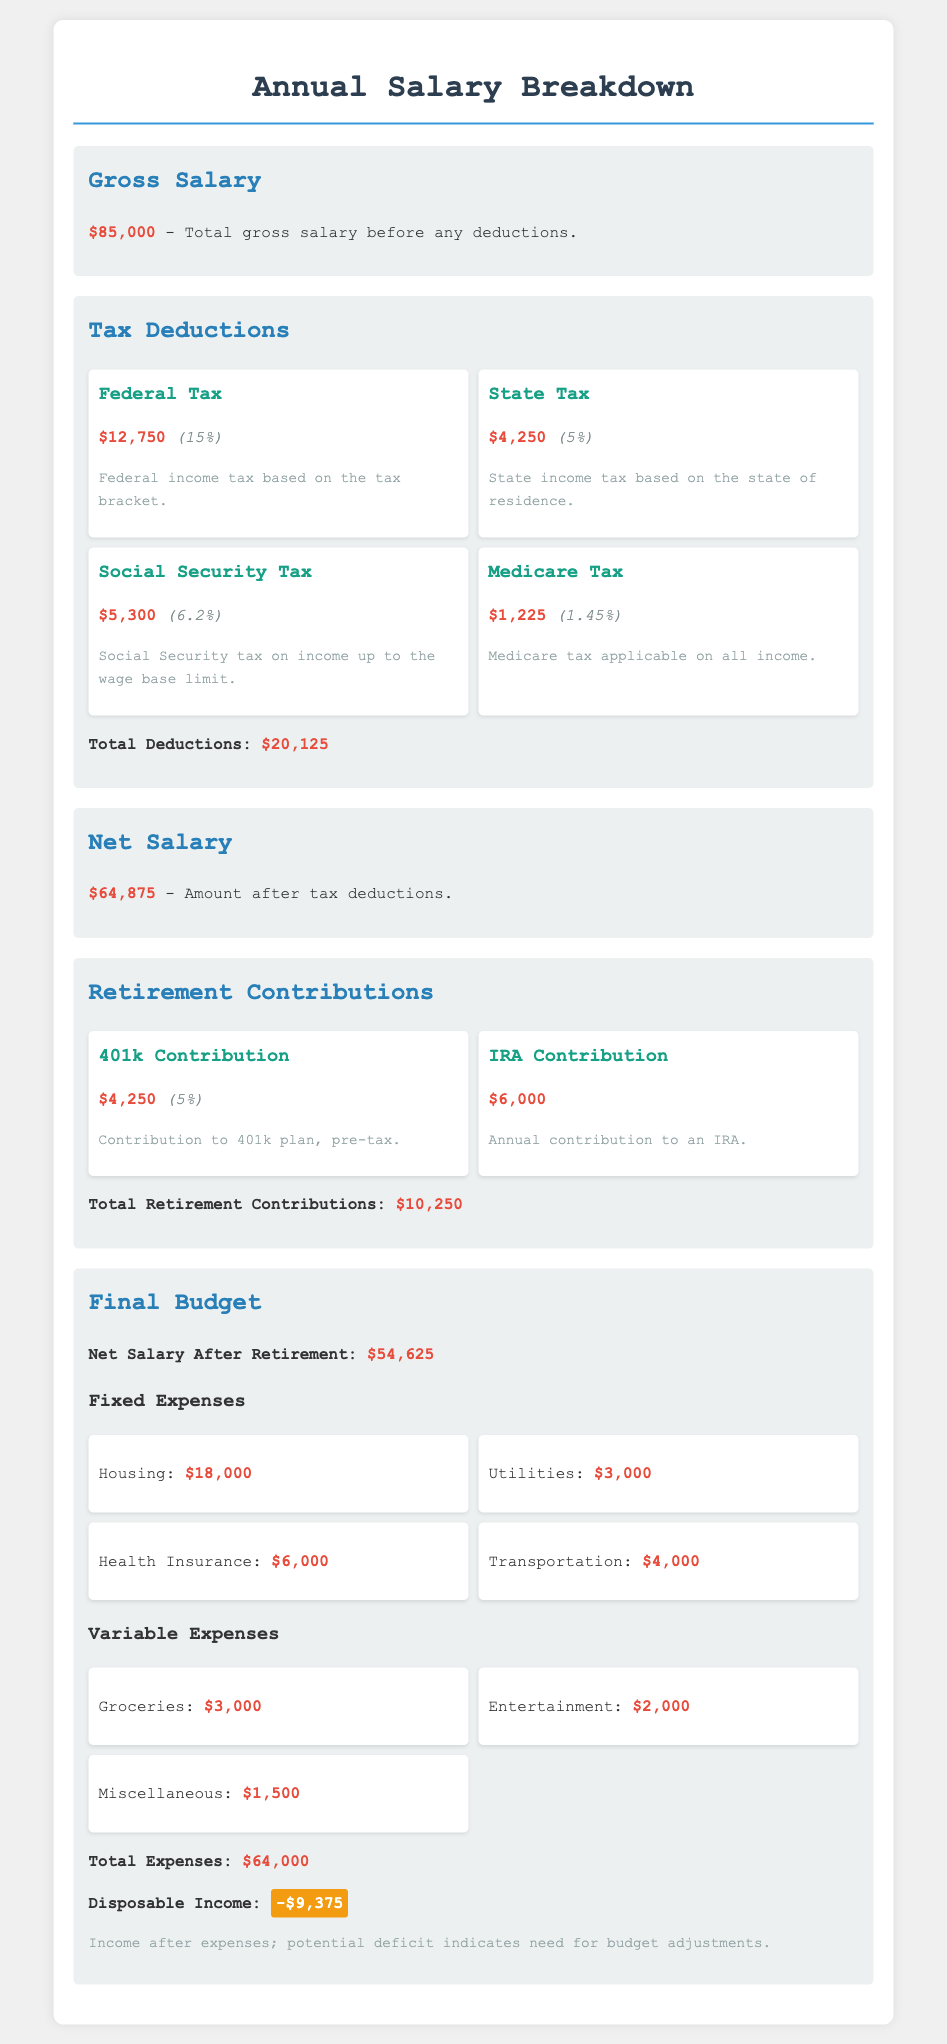what is the gross salary? The gross salary is stated in the document as the total salary before deductions, which is $85,000.
Answer: $85,000 what is the total amount of tax deductions? The total deductions amount is provided in the section on tax deductions, which totals $20,125.
Answer: $20,125 how much is contributed to the 401k? The document indicates the contribution to the 401k is $4,250.
Answer: $4,250 what is the net salary after tax deductions? The net salary after tax deductions is detailed in the document as $64,875.
Answer: $64,875 what is the disposable income? The document specifies that the disposable income is -$9,375, indicating a deficit.
Answer: -$9,375 what percentage of the gross salary is the federal tax? The federal tax amount is $12,750, which is 15% of the gross salary.
Answer: 15% how much are the total retirement contributions? The total retirement contributions listed in the document amount to $10,250.
Answer: $10,250 what are the fixed expenses for housing? The housing expense in the fixed expenses section is $18,000.
Answer: $18,000 what is the total amount spent on utilities? The document shows that the total spent on utilities is $3,000.
Answer: $3,000 what does the term "net salary after retirement" refer to? This term refers to the amount remaining after both tax deductions and retirement contributions, which is $54,625.
Answer: $54,625 